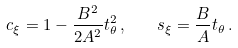Convert formula to latex. <formula><loc_0><loc_0><loc_500><loc_500>c _ { \xi } = 1 - \frac { B ^ { 2 } } { 2 A ^ { 2 } } t _ { \theta } ^ { 2 } \, , \quad s _ { \xi } = \frac { B } { A } t _ { \theta } \, .</formula> 